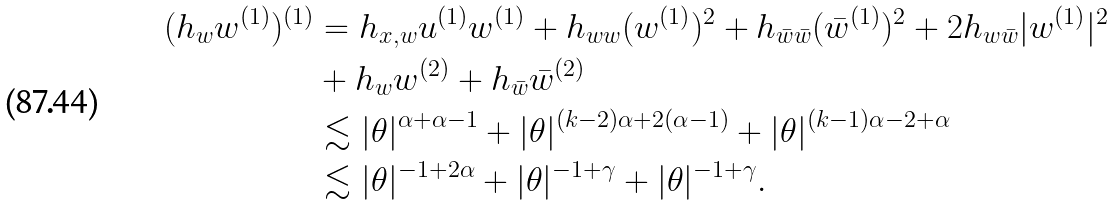Convert formula to latex. <formula><loc_0><loc_0><loc_500><loc_500>( h _ { w } w ^ { ( 1 ) } ) ^ { ( 1 ) } & = h _ { x , w } u ^ { ( 1 ) } w ^ { ( 1 ) } + h _ { w w } ( w ^ { ( 1 ) } ) ^ { 2 } + h _ { \bar { w } \bar { w } } ( \bar { w } ^ { ( 1 ) } ) ^ { 2 } + 2 h _ { w \bar { w } } | w ^ { ( 1 ) } | ^ { 2 } \\ & + h _ { w } w ^ { ( 2 ) } + h _ { \bar { w } } \bar { w } ^ { ( 2 ) } \\ & \lesssim | \theta | ^ { \alpha + \alpha - 1 } + | \theta | ^ { ( k - 2 ) \alpha + 2 ( \alpha - 1 ) } + | \theta | ^ { ( k - 1 ) \alpha - 2 + \alpha } \\ & \lesssim | \theta | ^ { - 1 + 2 \alpha } + | \theta | ^ { - 1 + \gamma } + | \theta | ^ { - 1 + \gamma } .</formula> 